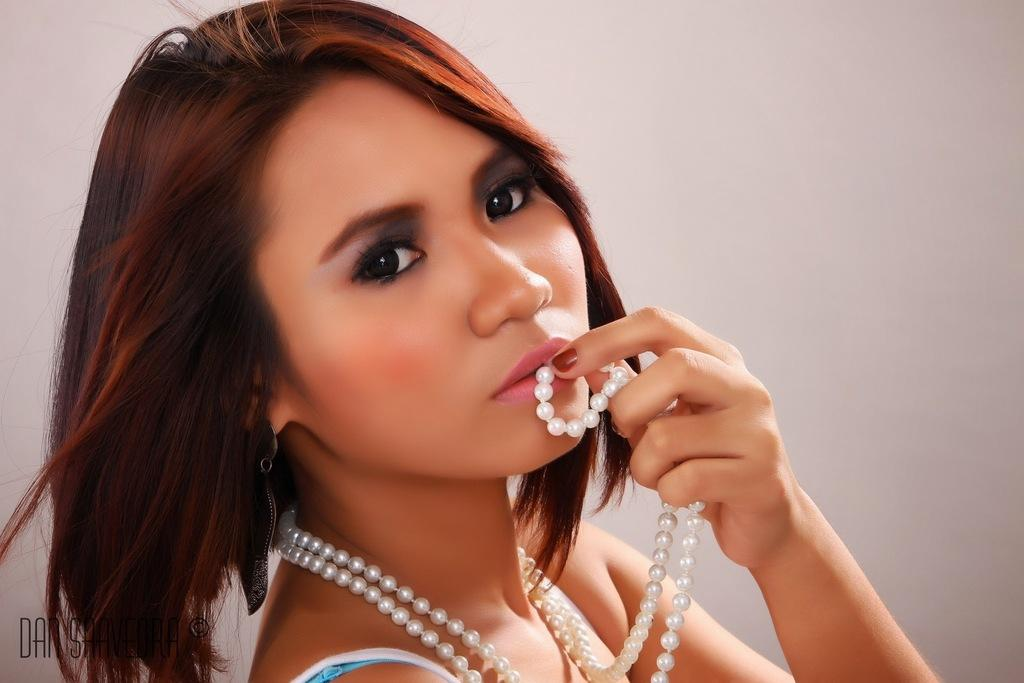Who is present in the image? There is a woman in the image. What is the woman holding? The woman is holding a pearl chain. What can be seen behind the woman? There is a plain wall in the background of the image. Where is the text located in the image? The text is in the bottom left corner of the image. What type of mint is growing on the wall in the image? There is no mint growing on the wall in the image; it is a plain wall with no vegetation. What type of chain is the woman holding in the image? The woman is holding a pearl chain, as mentioned in the conversation. 